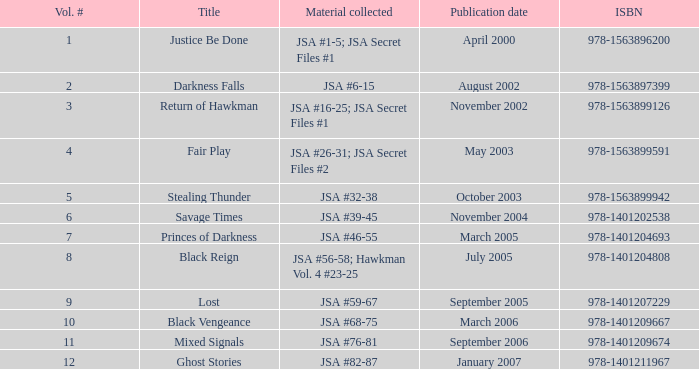What is the count of volume numbers for the title darkness falls? 2.0. 